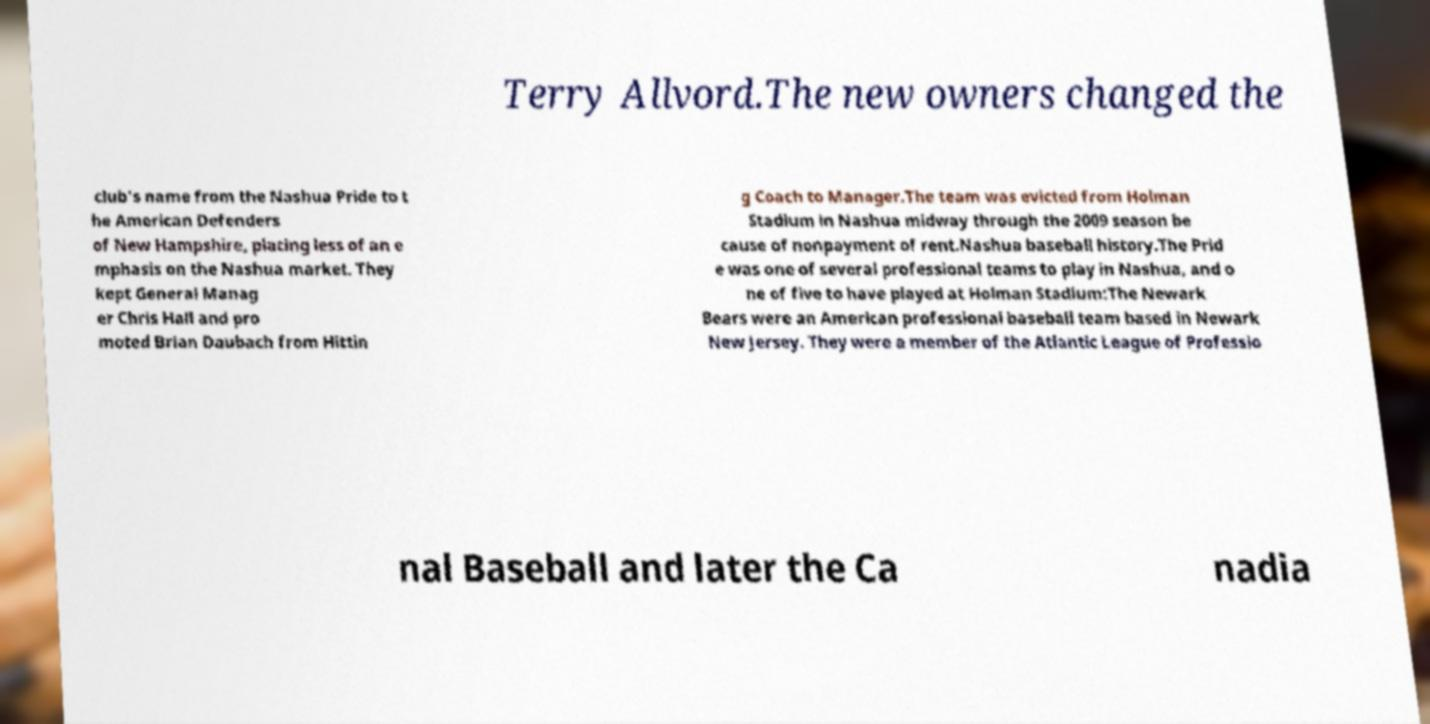Could you assist in decoding the text presented in this image and type it out clearly? Terry Allvord.The new owners changed the club's name from the Nashua Pride to t he American Defenders of New Hampshire, placing less of an e mphasis on the Nashua market. They kept General Manag er Chris Hall and pro moted Brian Daubach from Hittin g Coach to Manager.The team was evicted from Holman Stadium in Nashua midway through the 2009 season be cause of nonpayment of rent.Nashua baseball history.The Prid e was one of several professional teams to play in Nashua, and o ne of five to have played at Holman Stadium:The Newark Bears were an American professional baseball team based in Newark New Jersey. They were a member of the Atlantic League of Professio nal Baseball and later the Ca nadia 